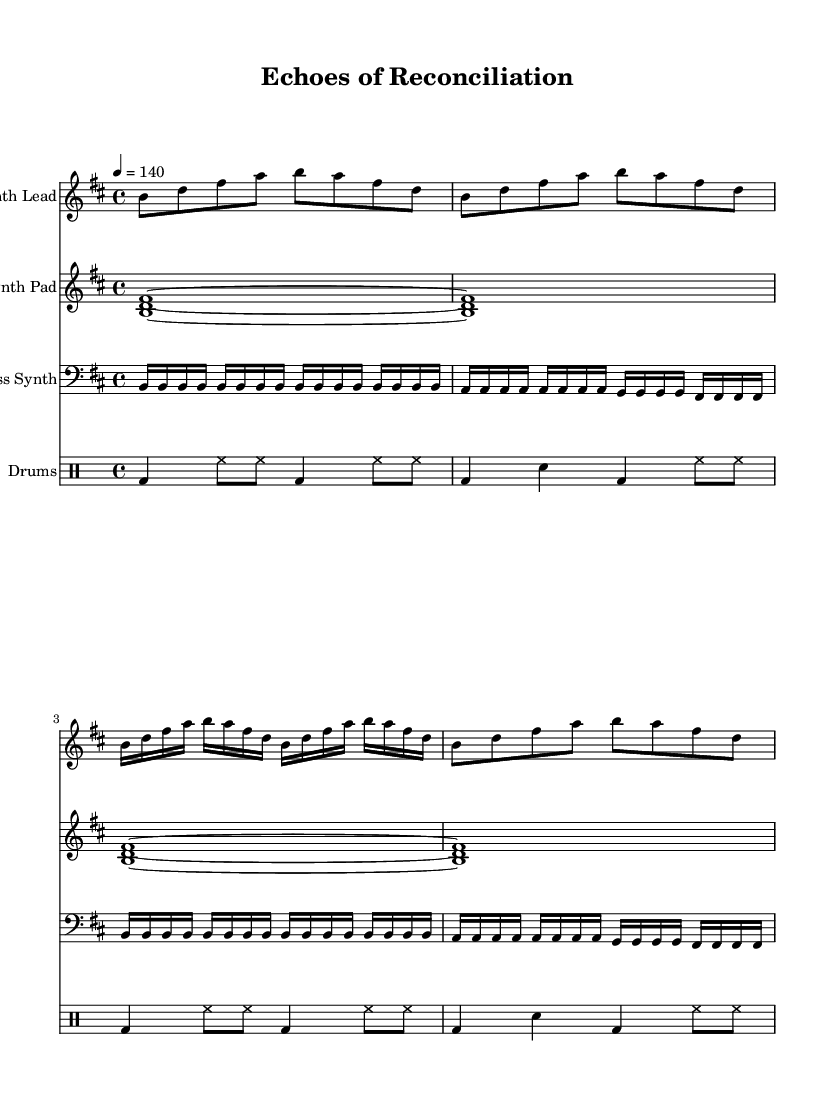What is the key signature of this music? The key signature indicated in the music is B minor, as it has two sharps (F# and C#) which corresponds to the B minor scale.
Answer: B minor What is the time signature of this piece? The time signature shown in the music is 4/4, which means there are four beats in each measure, and the quarter note receives one beat.
Answer: 4/4 What is the tempo of this piece? The tempo indicated is 140 beats per minute, as shown by the marking "4 = 140", meaning one quarter note equals 140 beats per minute.
Answer: 140 How many different instruments are used in this score? The score features four different staves, which indicates four distinct instruments: Synth Lead, Synth Pad, Bass Synth, and Drums.
Answer: Four What rhythmic pattern is predominantly used in the drum section? The drum pattern primarily consists of a alternating kick, snare, and hi-hat rhythm, seen through the consistent use of bass drum (bd), snare drum (sn), and hi-hat (hh) notation.
Answer: Alternating rhythm What is the overall mood suggested by the title of the piece? The title "Echoes of Reconciliation" suggests a mood of harmony and resolution, which aligns with the high-energy and uplifting nature of trance music while addressing themes of conflict resolution.
Answer: Harmony 